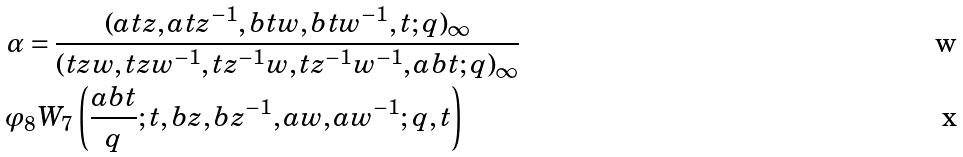Convert formula to latex. <formula><loc_0><loc_0><loc_500><loc_500>\alpha & = \frac { ( a t z , a t z ^ { - 1 } , b t w , b t w ^ { - 1 } , t ; q ) _ { \infty } } { ( t z w , t z w ^ { - 1 } , t z ^ { - 1 } w , t z ^ { - 1 } w ^ { - 1 } , a b t ; q ) _ { \infty } } \\ \varphi & _ { 8 } W _ { 7 } \left ( \frac { a b t } { q } ; t , b z , b z ^ { - 1 } , a w , a w ^ { - 1 } ; q , t \right )</formula> 